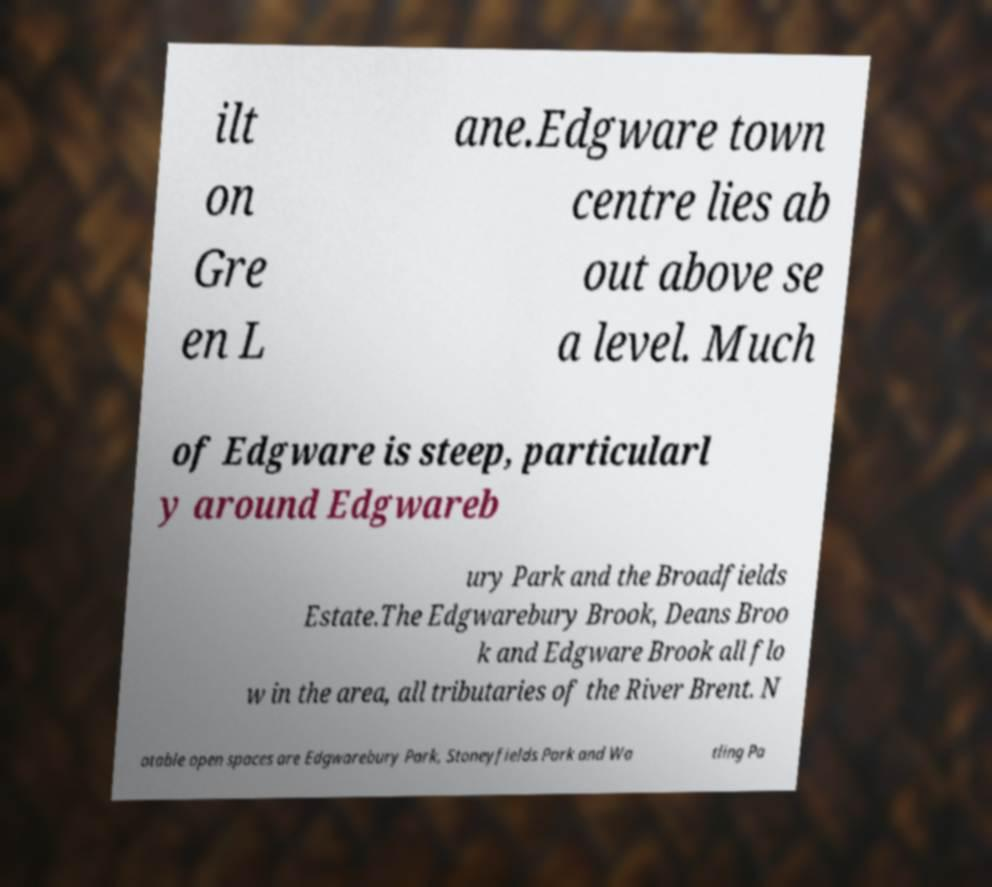Please read and relay the text visible in this image. What does it say? ilt on Gre en L ane.Edgware town centre lies ab out above se a level. Much of Edgware is steep, particularl y around Edgwareb ury Park and the Broadfields Estate.The Edgwarebury Brook, Deans Broo k and Edgware Brook all flo w in the area, all tributaries of the River Brent. N otable open spaces are Edgwarebury Park, Stoneyfields Park and Wa tling Pa 